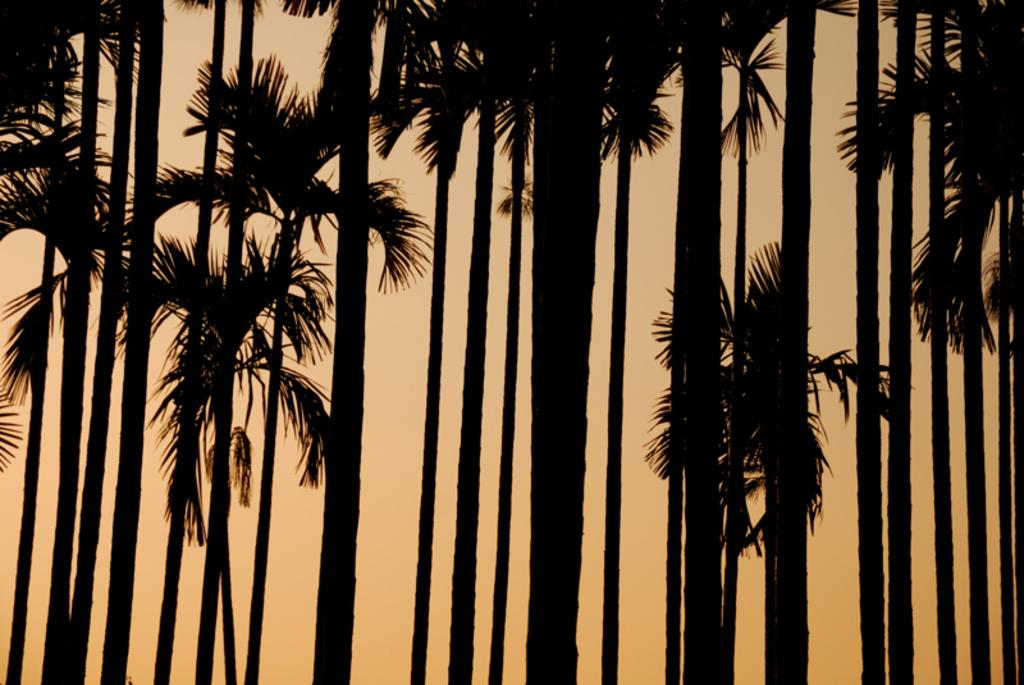What can be seen in the background of the image? There are many trees in the image. What is the time of day suggested by the image? There is a sunset visible in the image, which suggests that it is late afternoon or early evening. What type of mice can be seen running on the back of the trees in the image? There are no mice present in the image; it features trees and a sunset. Can you tell me how many porters are carrying luggage in the image? There is no reference to porters or luggage in the image; it only shows trees and a sunset. 